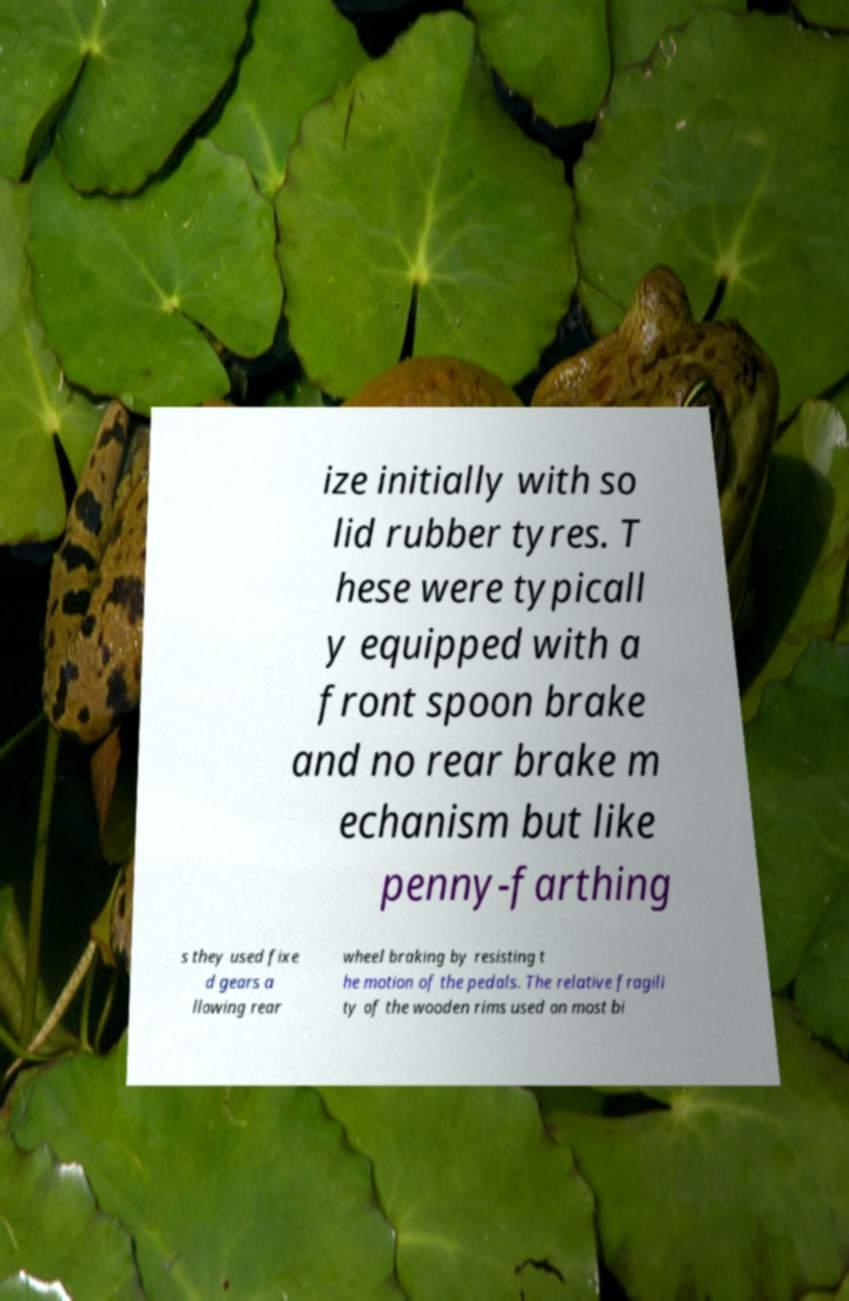Can you accurately transcribe the text from the provided image for me? ize initially with so lid rubber tyres. T hese were typicall y equipped with a front spoon brake and no rear brake m echanism but like penny-farthing s they used fixe d gears a llowing rear wheel braking by resisting t he motion of the pedals. The relative fragili ty of the wooden rims used on most bi 